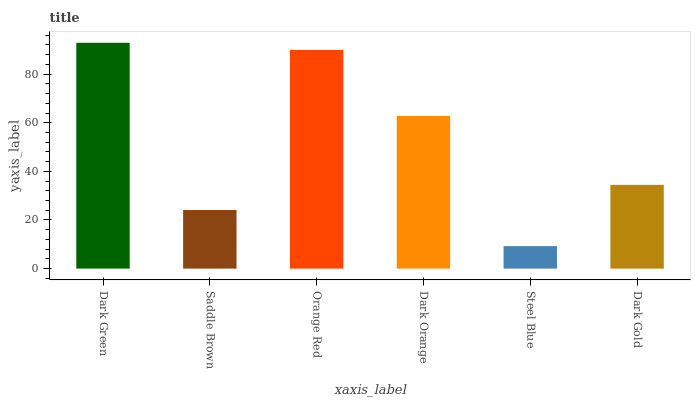Is Steel Blue the minimum?
Answer yes or no. Yes. Is Dark Green the maximum?
Answer yes or no. Yes. Is Saddle Brown the minimum?
Answer yes or no. No. Is Saddle Brown the maximum?
Answer yes or no. No. Is Dark Green greater than Saddle Brown?
Answer yes or no. Yes. Is Saddle Brown less than Dark Green?
Answer yes or no. Yes. Is Saddle Brown greater than Dark Green?
Answer yes or no. No. Is Dark Green less than Saddle Brown?
Answer yes or no. No. Is Dark Orange the high median?
Answer yes or no. Yes. Is Dark Gold the low median?
Answer yes or no. Yes. Is Saddle Brown the high median?
Answer yes or no. No. Is Orange Red the low median?
Answer yes or no. No. 